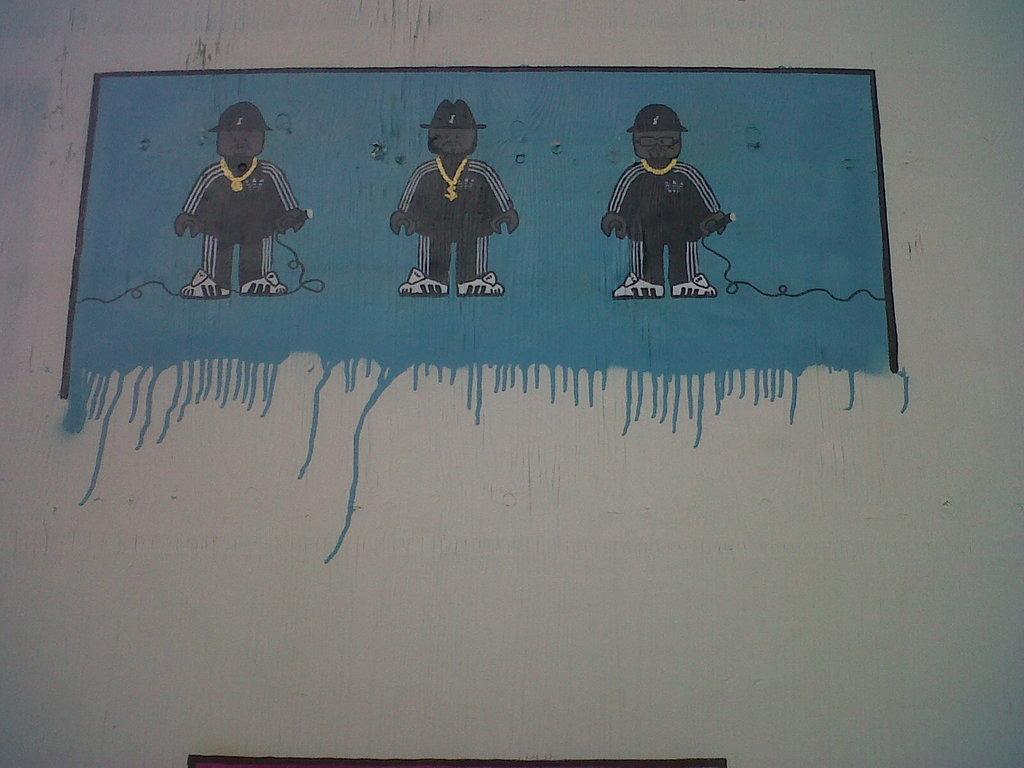Can you describe this image briefly? In this image I can see the white colored surface and on it I can see the painting of three persons standing which is black, white and blue in color. 